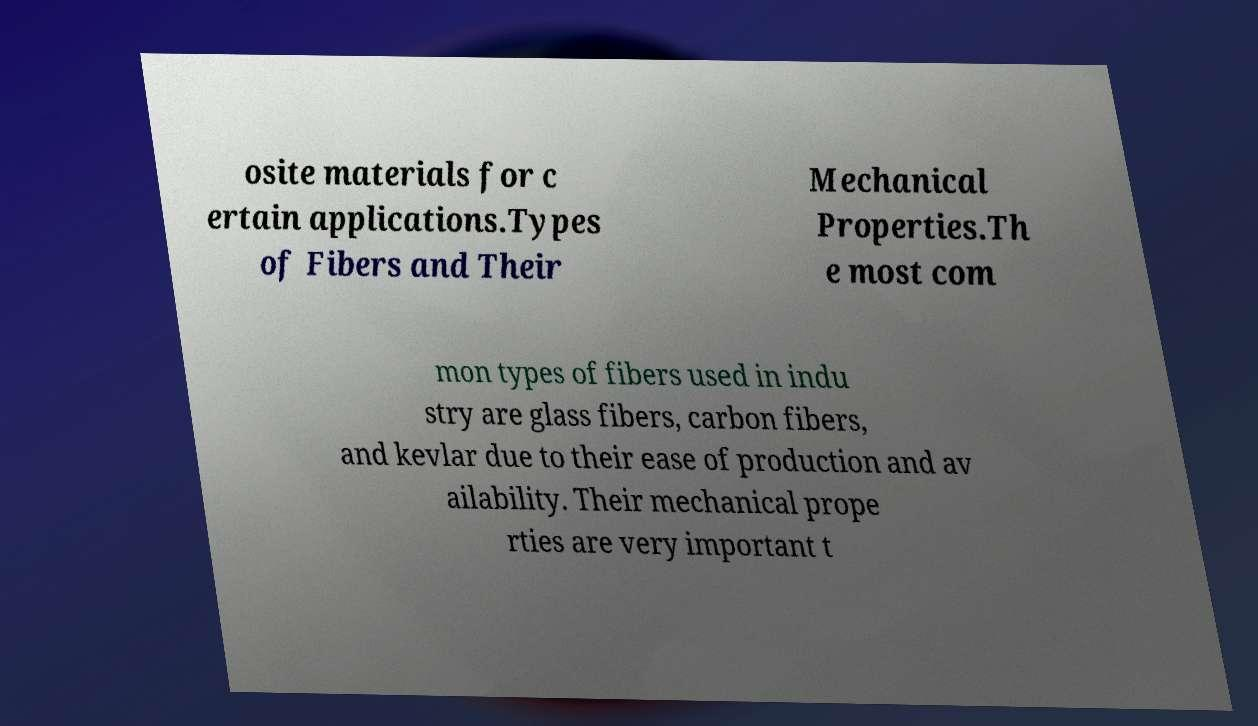Can you accurately transcribe the text from the provided image for me? osite materials for c ertain applications.Types of Fibers and Their Mechanical Properties.Th e most com mon types of fibers used in indu stry are glass fibers, carbon fibers, and kevlar due to their ease of production and av ailability. Their mechanical prope rties are very important t 